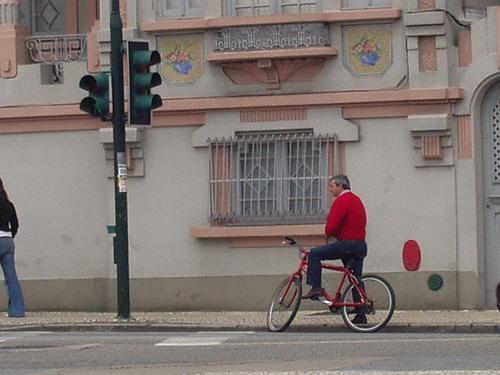Question: where was the photo taken?
Choices:
A. In a park.
B. On a street.
C. In a mall.
D. At a beach.
Answer with the letter. Answer: B Question: who is on the bicycle?
Choices:
A. Boy.
B. Girl.
C. Mom.
D. Man.
Answer with the letter. Answer: D Question: what color is the bicycle?
Choices:
A. White.
B. Red.
C. Pink.
D. Yellow.
Answer with the letter. Answer: B Question: where is the traffic light signal?
Choices:
A. In the road.
B. On the line.
C. At the intersection.
D. On the pole.
Answer with the letter. Answer: D 